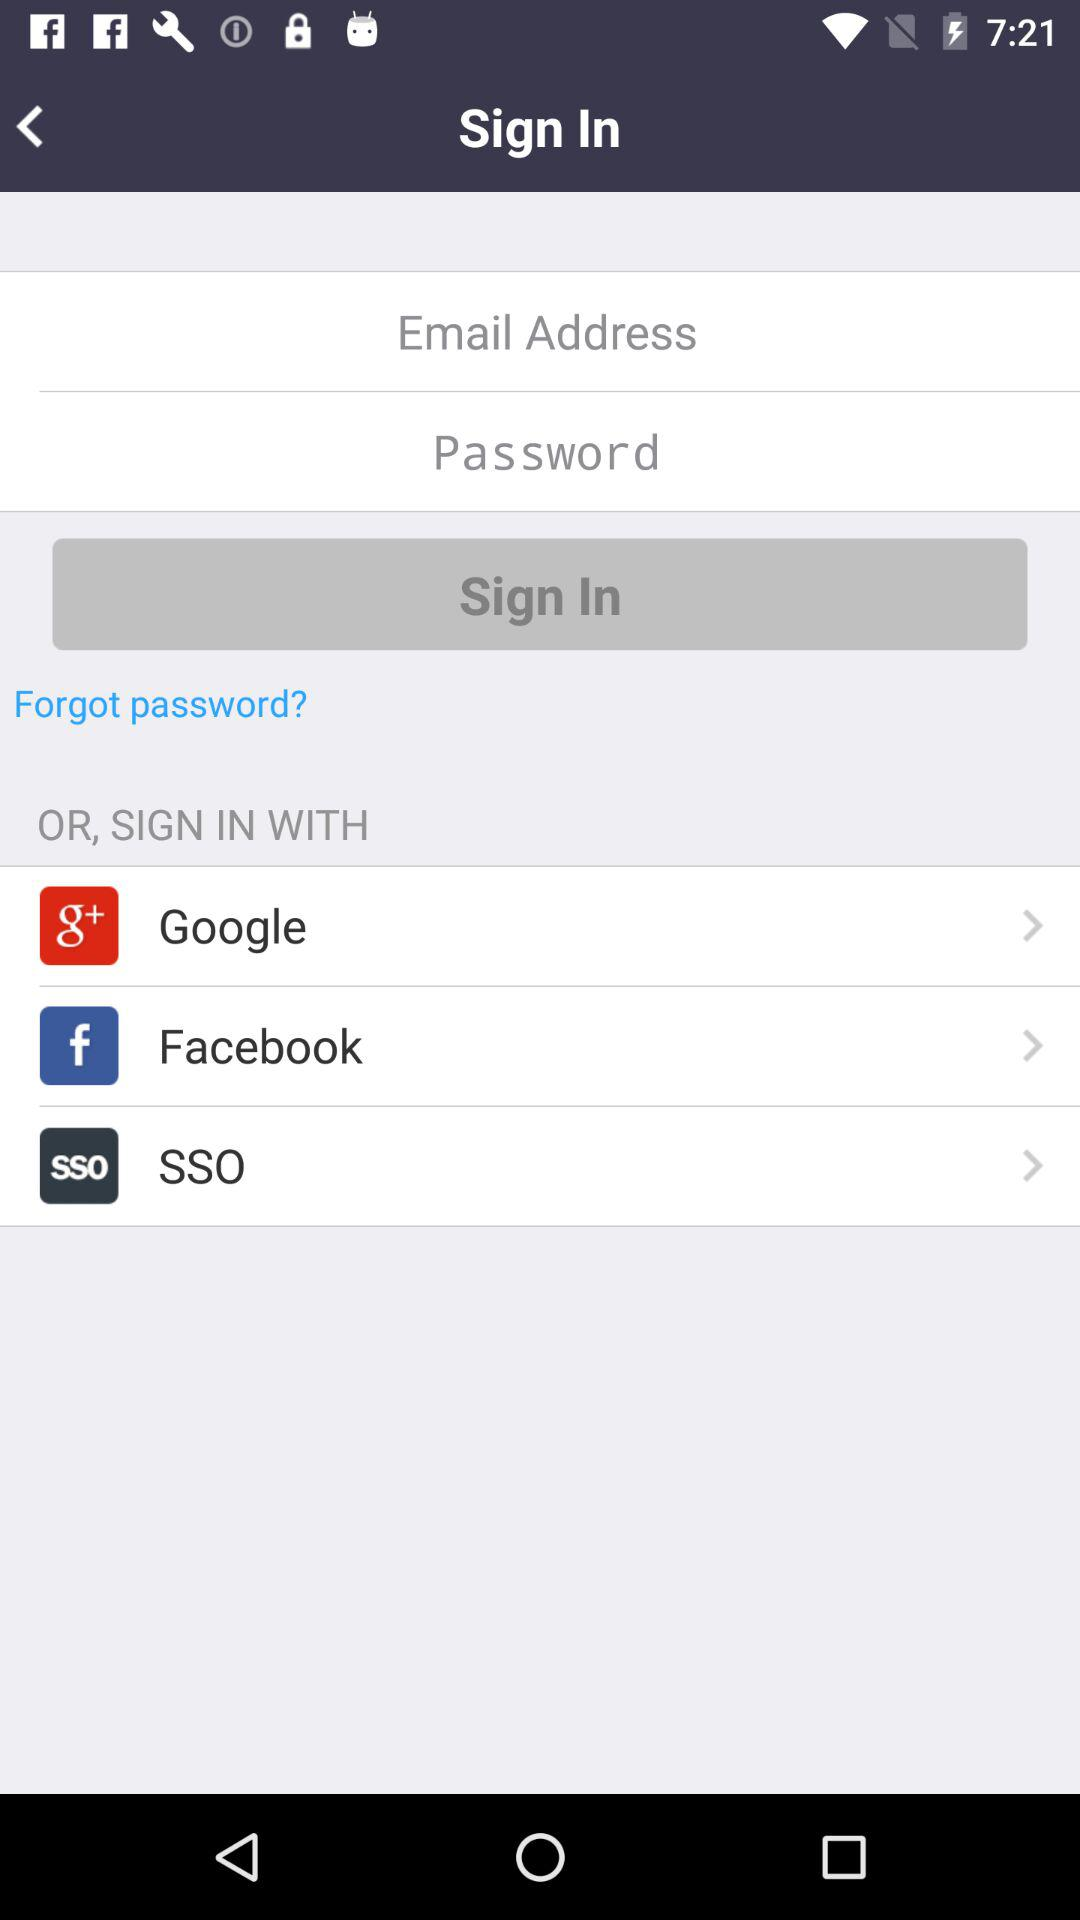What is the name? The name is Sam Brown. 